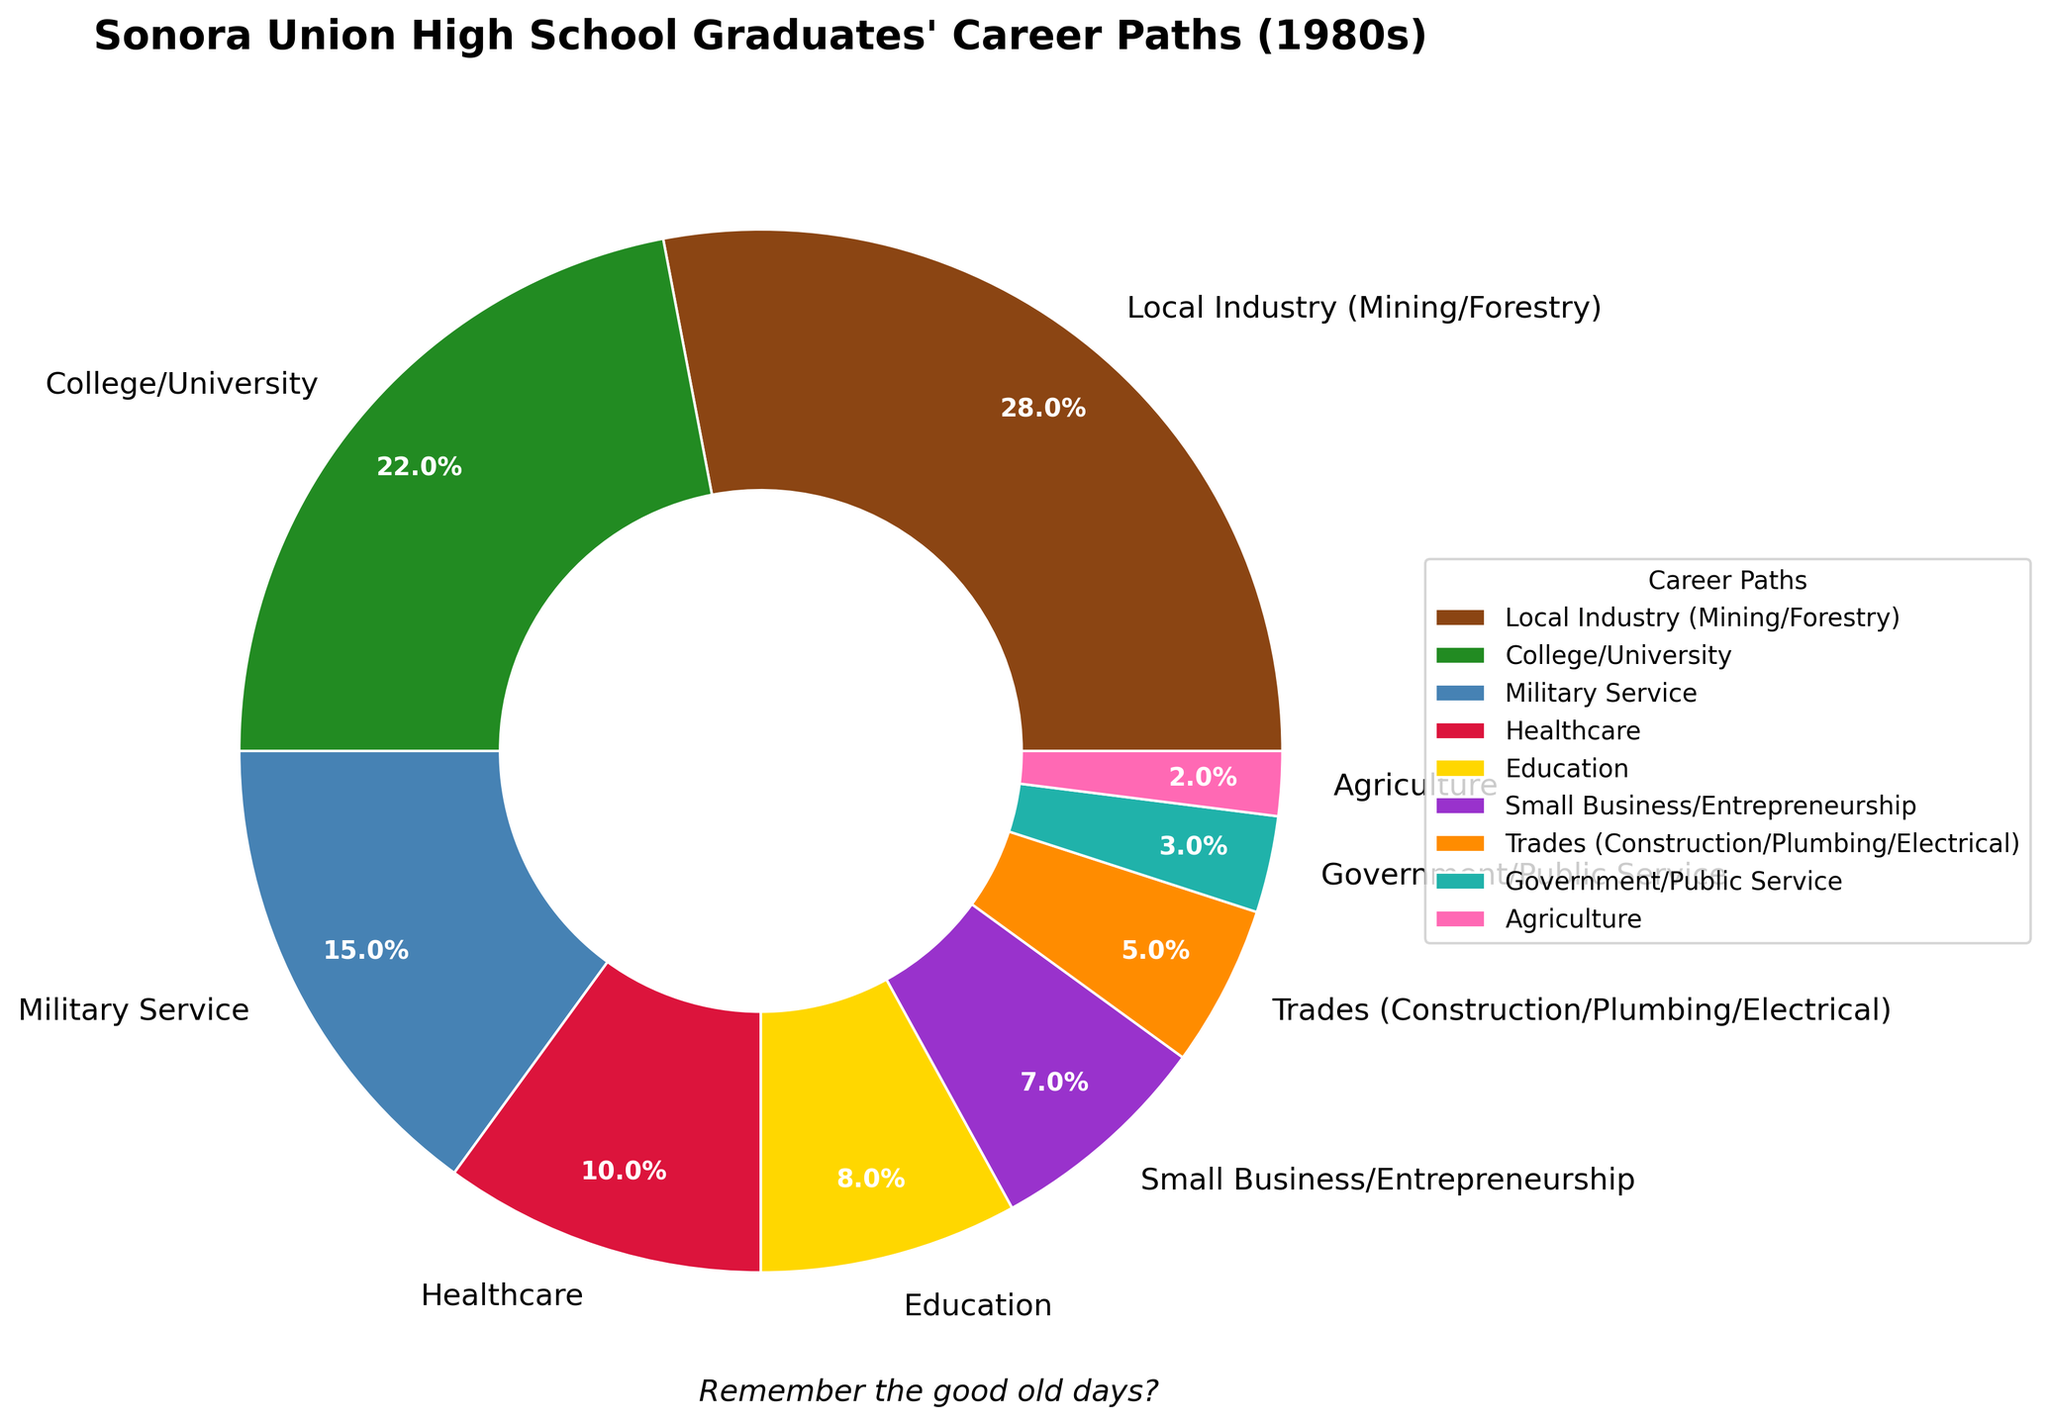What's the total percentage of graduates going into Local Industry and Military Service combined? Add the percentages of Local Industry (28%) and Military Service (15%). 28% + 15% = 43%.
Answer: 43% Which career path has the smallest percentage of graduates? Look at the pie chart and find the career path with the smallest slice. Agriculture has the smallest percentage at 2%.
Answer: Agriculture Are there more graduates pursuing careers in College/University or Healthcare? Compare the percentages of College/University (22%) and Healthcare (10%). 22% is greater than 10%.
Answer: College/University What is the percentage difference between graduates going into Education and Trades? Subtract the percentage of Trades (5%) from Education (8%). 8% - 5% = 3%.
Answer: 3% Which fields together make up more than half of the graduates' career paths? Sum the percentages until you reach more than 50%. Local Industry (28%) and College/University (22%) together make 50%, so you need to consider the next one, Military Service (15%). 28% + 22% + 15% = 65%.
Answer: Local Industry, College/University, and Military Service What is the median percentage of all the career paths? List all the percentages in order: 2%, 3%, 5%, 7%, 8%, 10%, 15%, 22%, 28%. The middle value is the fifth value when listed in order. The fifth value is 8%.
Answer: 8% Which career path is represented by the orange color? Identify the career path that is colored orange in the pie chart. Small Business/Entrepreneurship is colored orange.
Answer: Small Business/Entrepreneurship How does the percentage of graduates going into Government/Public Service compare to those preferring Small Business/Entrepreneurship? Compare the percentages of Government/Public Service (3%) and Small Business/Entrepreneurship (7%). 3% is less than 7%.
Answer: Government/Public Service is less If you add the percentages of those entering Small Business/Entrepreneurship and Healthcare, what percentage do you get? Add the percentages of Small Business/Entrepreneurship (7%) and Healthcare (10%). 7% + 10% = 17%.
Answer: 17% Which three career paths have the highest percentages? Identify the three largest slices in the pie chart. Local Industry (28%), College/University (22%), and Military Service (15%) have the highest percentages.
Answer: Local Industry, College/University, Military Service 